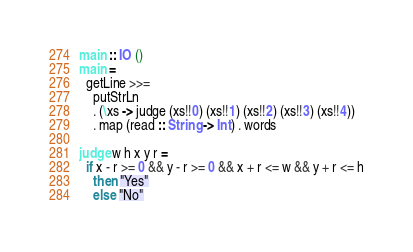<code> <loc_0><loc_0><loc_500><loc_500><_Haskell_>main :: IO ()
main =
  getLine >>=
    putStrLn
    . (\xs -> judge (xs!!0) (xs!!1) (xs!!2) (xs!!3) (xs!!4))
    . map (read :: String -> Int) . words

judge w h x y r =
  if x - r >= 0 && y - r >= 0 && x + r <= w && y + r <= h
    then "Yes"
    else "No"

</code> 